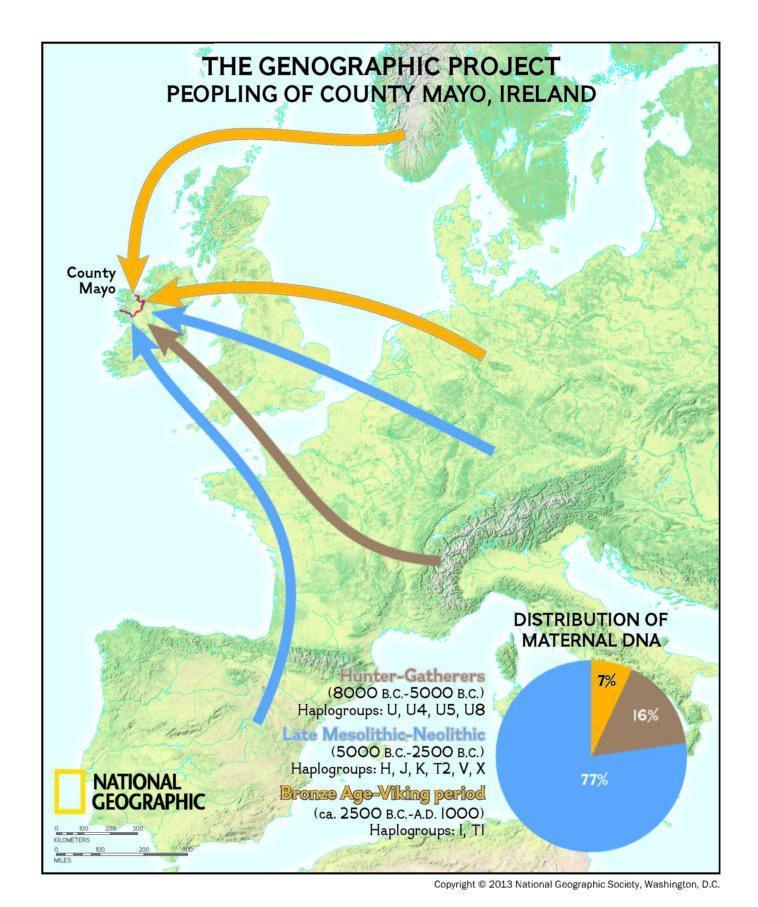What percentage of the maternal DNAs are from hunter-gatherers in County Mayo of Ireland?
Answer the question with a short phrase. 16% What percentage of the maternal DNAs are from Late Mesolithic-Neolithic in County Mayo of Ireland? 77% 